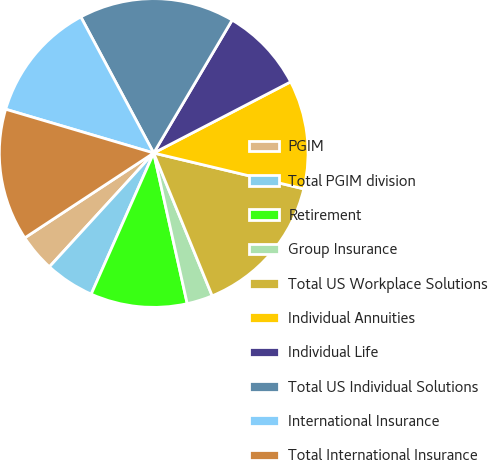Convert chart. <chart><loc_0><loc_0><loc_500><loc_500><pie_chart><fcel>PGIM<fcel>Total PGIM division<fcel>Retirement<fcel>Group Insurance<fcel>Total US Workplace Solutions<fcel>Individual Annuities<fcel>Individual Life<fcel>Total US Individual Solutions<fcel>International Insurance<fcel>Total International Insurance<nl><fcel>3.93%<fcel>5.17%<fcel>10.12%<fcel>2.7%<fcel>15.08%<fcel>11.36%<fcel>8.89%<fcel>16.31%<fcel>12.6%<fcel>13.84%<nl></chart> 